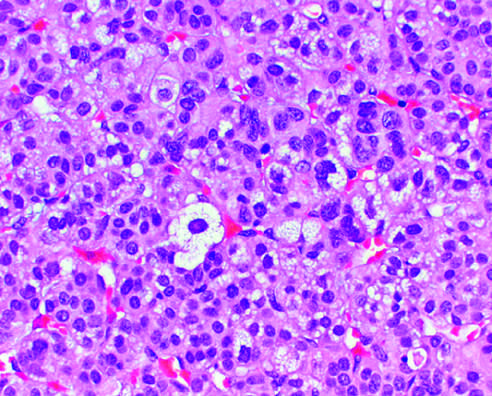what is there in the figure?
Answer the question using a single word or phrase. Mild nuclear pleomorphism 